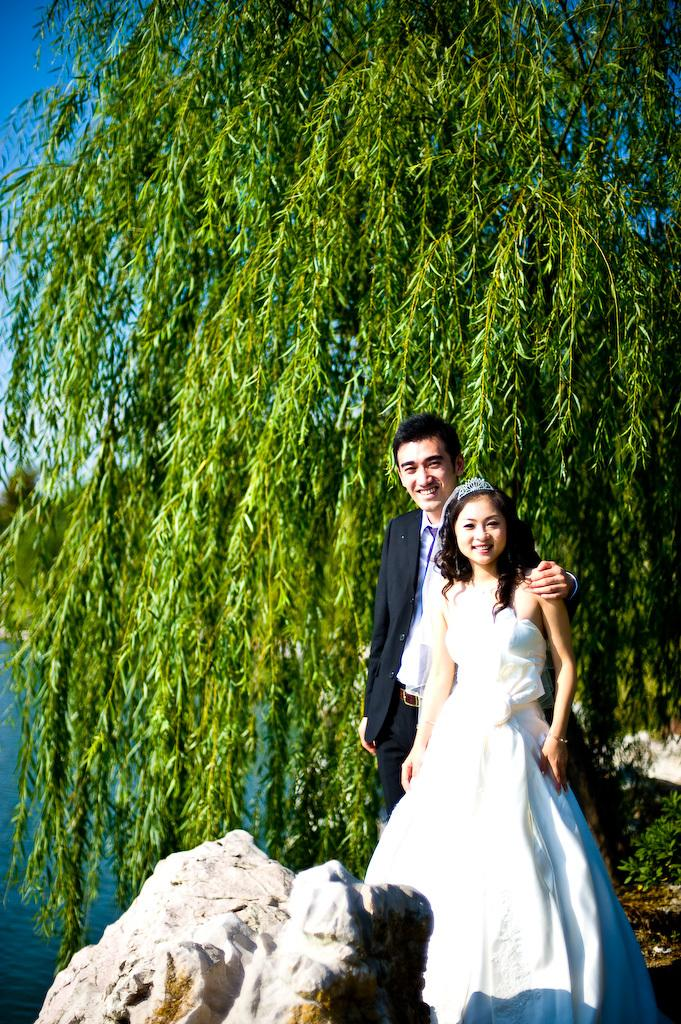Who is present in the image? There is a man and a woman wearing a crown in the image. Where are the man and woman located in the image? They are on the right side of the image. What can be seen in the background of the image? There is water, greenery, and the sky visible in the background of the image. What type of can is being used for treatment in the image? There is no can or treatment present in the image. How many cubs can be seen playing with the man in the image? There are no cubs present in the image. 